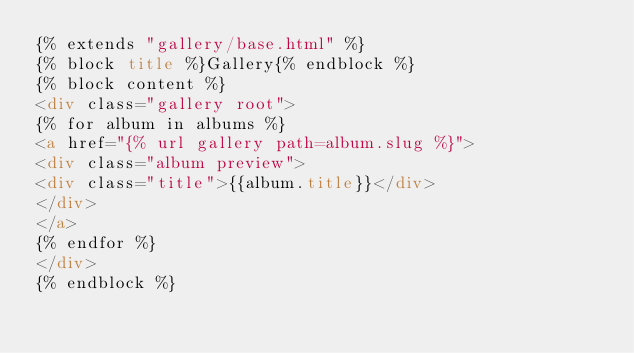Convert code to text. <code><loc_0><loc_0><loc_500><loc_500><_HTML_>{% extends "gallery/base.html" %}
{% block title %}Gallery{% endblock %}
{% block content %}
<div class="gallery root">
{% for album in albums %}
<a href="{% url gallery path=album.slug %}">
<div class="album preview">
<div class="title">{{album.title}}</div>
</div>
</a>
{% endfor %}
</div>
{% endblock %}
</code> 